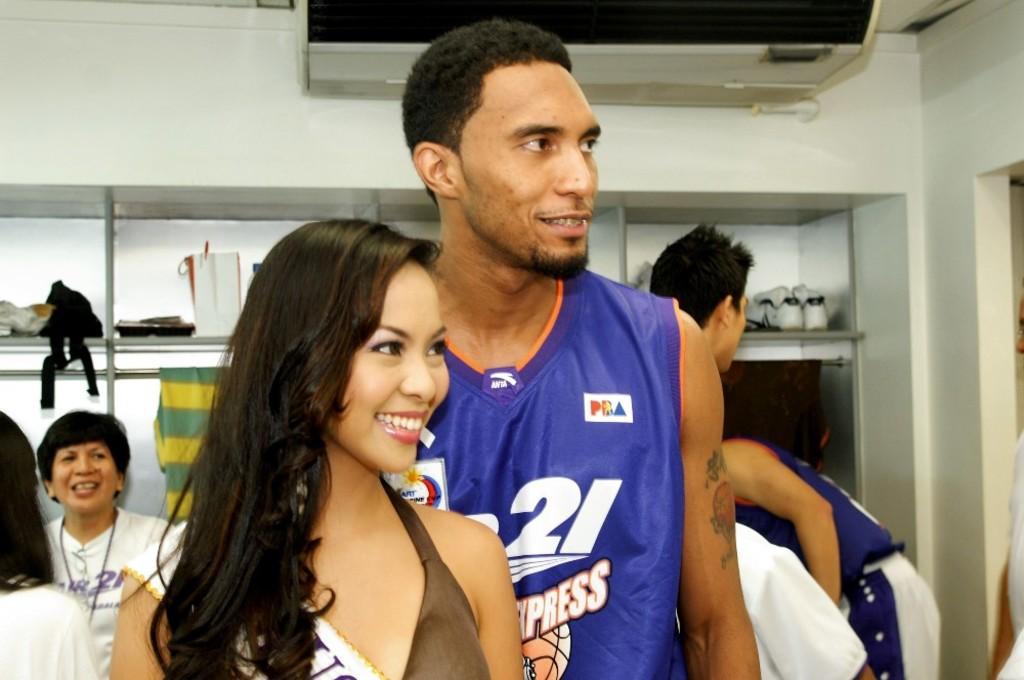What brand of jersey is this?
Keep it short and to the point. Pca. 